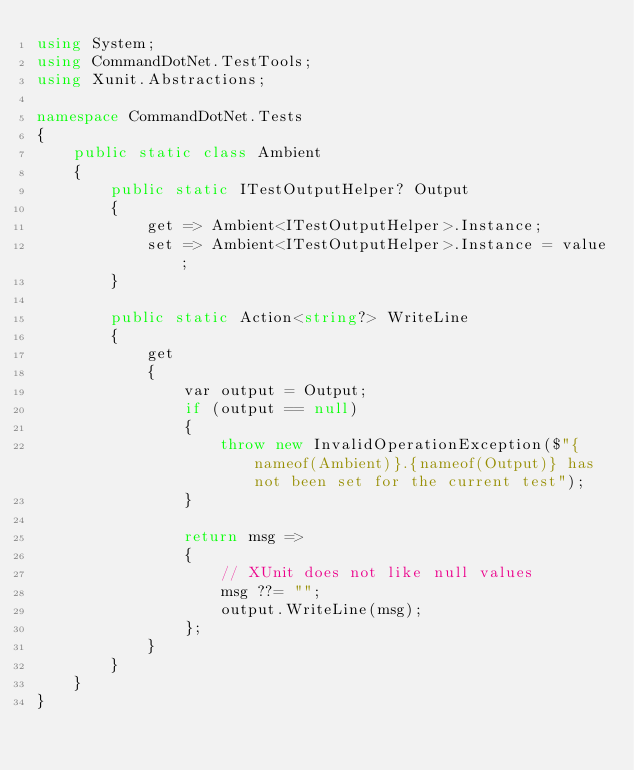<code> <loc_0><loc_0><loc_500><loc_500><_C#_>using System;
using CommandDotNet.TestTools;
using Xunit.Abstractions;

namespace CommandDotNet.Tests
{
    public static class Ambient
    {
        public static ITestOutputHelper? Output
        {
            get => Ambient<ITestOutputHelper>.Instance;
            set => Ambient<ITestOutputHelper>.Instance = value;
        }

        public static Action<string?> WriteLine
        {
            get
            {
                var output = Output;
                if (output == null)
                {
                    throw new InvalidOperationException($"{nameof(Ambient)}.{nameof(Output)} has not been set for the current test");
                }

                return msg =>
                {
                    // XUnit does not like null values
                    msg ??= "";
                    output.WriteLine(msg);
                };
            }
        }
    }
}</code> 